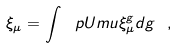Convert formula to latex. <formula><loc_0><loc_0><loc_500><loc_500>\xi _ { \mu } = \int \ p U m u \xi ^ { g } _ { \mu } d g \ ,</formula> 